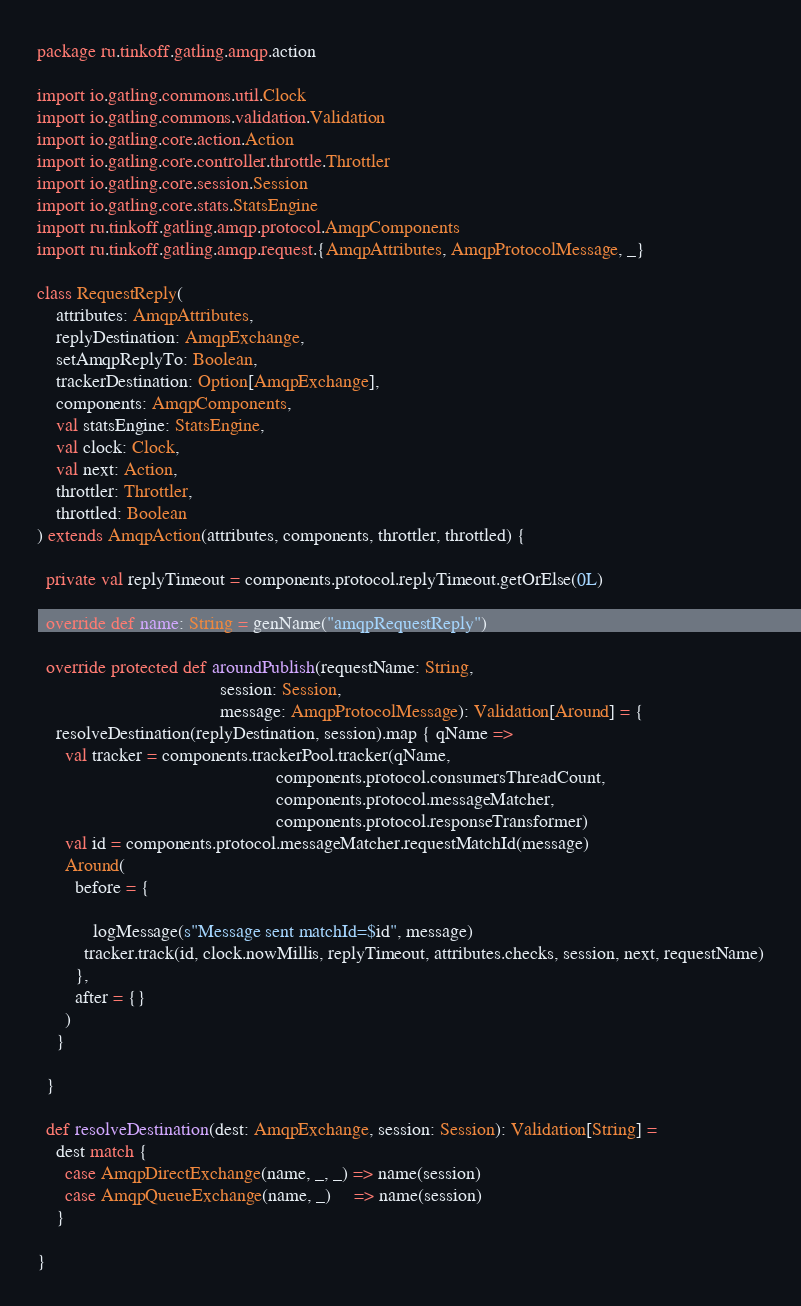Convert code to text. <code><loc_0><loc_0><loc_500><loc_500><_Scala_>package ru.tinkoff.gatling.amqp.action

import io.gatling.commons.util.Clock
import io.gatling.commons.validation.Validation
import io.gatling.core.action.Action
import io.gatling.core.controller.throttle.Throttler
import io.gatling.core.session.Session
import io.gatling.core.stats.StatsEngine
import ru.tinkoff.gatling.amqp.protocol.AmqpComponents
import ru.tinkoff.gatling.amqp.request.{AmqpAttributes, AmqpProtocolMessage, _}

class RequestReply(
    attributes: AmqpAttributes,
    replyDestination: AmqpExchange,
    setAmqpReplyTo: Boolean,
    trackerDestination: Option[AmqpExchange],
    components: AmqpComponents,
    val statsEngine: StatsEngine,
    val clock: Clock,
    val next: Action,
    throttler: Throttler,
    throttled: Boolean
) extends AmqpAction(attributes, components, throttler, throttled) {

  private val replyTimeout = components.protocol.replyTimeout.getOrElse(0L)

  override def name: String = genName("amqpRequestReply")

  override protected def aroundPublish(requestName: String,
                                       session: Session,
                                       message: AmqpProtocolMessage): Validation[Around] = {
    resolveDestination(replyDestination, session).map { qName =>
      val tracker = components.trackerPool.tracker(qName,
                                                   components.protocol.consumersThreadCount,
                                                   components.protocol.messageMatcher,
                                                   components.protocol.responseTransformer)
      val id = components.protocol.messageMatcher.requestMatchId(message)
      Around(
        before = {

            logMessage(s"Message sent matchId=$id", message)
          tracker.track(id, clock.nowMillis, replyTimeout, attributes.checks, session, next, requestName)
        },
        after = {}
      )
    }

  }

  def resolveDestination(dest: AmqpExchange, session: Session): Validation[String] =
    dest match {
      case AmqpDirectExchange(name, _, _) => name(session)
      case AmqpQueueExchange(name, _)     => name(session)
    }

}
</code> 